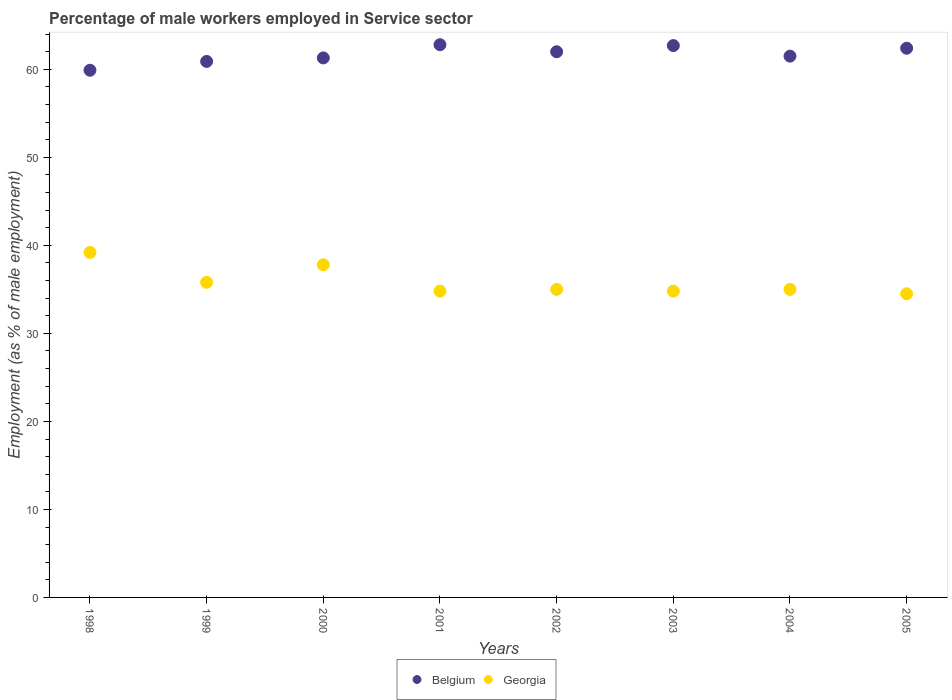What is the percentage of male workers employed in Service sector in Georgia in 2003?
Your response must be concise. 34.8. Across all years, what is the maximum percentage of male workers employed in Service sector in Belgium?
Your answer should be very brief. 62.8. Across all years, what is the minimum percentage of male workers employed in Service sector in Georgia?
Keep it short and to the point. 34.5. What is the total percentage of male workers employed in Service sector in Belgium in the graph?
Give a very brief answer. 493.5. What is the difference between the percentage of male workers employed in Service sector in Belgium in 2001 and that in 2004?
Offer a terse response. 1.3. What is the difference between the percentage of male workers employed in Service sector in Belgium in 2003 and the percentage of male workers employed in Service sector in Georgia in 1999?
Your answer should be compact. 26.9. What is the average percentage of male workers employed in Service sector in Georgia per year?
Keep it short and to the point. 35.86. In the year 1998, what is the difference between the percentage of male workers employed in Service sector in Belgium and percentage of male workers employed in Service sector in Georgia?
Offer a very short reply. 20.7. What is the ratio of the percentage of male workers employed in Service sector in Belgium in 2000 to that in 2004?
Keep it short and to the point. 1. Is the difference between the percentage of male workers employed in Service sector in Belgium in 2000 and 2001 greater than the difference between the percentage of male workers employed in Service sector in Georgia in 2000 and 2001?
Provide a succinct answer. No. What is the difference between the highest and the second highest percentage of male workers employed in Service sector in Belgium?
Offer a very short reply. 0.1. What is the difference between the highest and the lowest percentage of male workers employed in Service sector in Georgia?
Make the answer very short. 4.7. Is the sum of the percentage of male workers employed in Service sector in Georgia in 1998 and 2003 greater than the maximum percentage of male workers employed in Service sector in Belgium across all years?
Offer a terse response. Yes. Does the percentage of male workers employed in Service sector in Belgium monotonically increase over the years?
Provide a succinct answer. No. How many years are there in the graph?
Make the answer very short. 8. Are the values on the major ticks of Y-axis written in scientific E-notation?
Make the answer very short. No. Does the graph contain any zero values?
Your answer should be compact. No. How are the legend labels stacked?
Your answer should be compact. Horizontal. What is the title of the graph?
Give a very brief answer. Percentage of male workers employed in Service sector. What is the label or title of the X-axis?
Give a very brief answer. Years. What is the label or title of the Y-axis?
Make the answer very short. Employment (as % of male employment). What is the Employment (as % of male employment) of Belgium in 1998?
Give a very brief answer. 59.9. What is the Employment (as % of male employment) in Georgia in 1998?
Your answer should be very brief. 39.2. What is the Employment (as % of male employment) of Belgium in 1999?
Your answer should be very brief. 60.9. What is the Employment (as % of male employment) of Georgia in 1999?
Offer a very short reply. 35.8. What is the Employment (as % of male employment) of Belgium in 2000?
Make the answer very short. 61.3. What is the Employment (as % of male employment) in Georgia in 2000?
Provide a succinct answer. 37.8. What is the Employment (as % of male employment) in Belgium in 2001?
Keep it short and to the point. 62.8. What is the Employment (as % of male employment) of Georgia in 2001?
Keep it short and to the point. 34.8. What is the Employment (as % of male employment) of Georgia in 2002?
Provide a succinct answer. 35. What is the Employment (as % of male employment) in Belgium in 2003?
Ensure brevity in your answer.  62.7. What is the Employment (as % of male employment) in Georgia in 2003?
Ensure brevity in your answer.  34.8. What is the Employment (as % of male employment) of Belgium in 2004?
Make the answer very short. 61.5. What is the Employment (as % of male employment) of Georgia in 2004?
Your response must be concise. 35. What is the Employment (as % of male employment) in Belgium in 2005?
Offer a terse response. 62.4. What is the Employment (as % of male employment) of Georgia in 2005?
Ensure brevity in your answer.  34.5. Across all years, what is the maximum Employment (as % of male employment) in Belgium?
Your response must be concise. 62.8. Across all years, what is the maximum Employment (as % of male employment) of Georgia?
Keep it short and to the point. 39.2. Across all years, what is the minimum Employment (as % of male employment) in Belgium?
Keep it short and to the point. 59.9. Across all years, what is the minimum Employment (as % of male employment) in Georgia?
Keep it short and to the point. 34.5. What is the total Employment (as % of male employment) of Belgium in the graph?
Your answer should be compact. 493.5. What is the total Employment (as % of male employment) of Georgia in the graph?
Provide a short and direct response. 286.9. What is the difference between the Employment (as % of male employment) of Belgium in 1998 and that in 2001?
Your response must be concise. -2.9. What is the difference between the Employment (as % of male employment) of Belgium in 1998 and that in 2002?
Your answer should be very brief. -2.1. What is the difference between the Employment (as % of male employment) in Belgium in 1998 and that in 2004?
Give a very brief answer. -1.6. What is the difference between the Employment (as % of male employment) of Georgia in 1998 and that in 2004?
Offer a terse response. 4.2. What is the difference between the Employment (as % of male employment) of Georgia in 1998 and that in 2005?
Ensure brevity in your answer.  4.7. What is the difference between the Employment (as % of male employment) of Belgium in 1999 and that in 2000?
Your response must be concise. -0.4. What is the difference between the Employment (as % of male employment) in Georgia in 1999 and that in 2000?
Make the answer very short. -2. What is the difference between the Employment (as % of male employment) in Georgia in 1999 and that in 2001?
Your answer should be very brief. 1. What is the difference between the Employment (as % of male employment) of Georgia in 1999 and that in 2002?
Ensure brevity in your answer.  0.8. What is the difference between the Employment (as % of male employment) in Belgium in 1999 and that in 2003?
Provide a short and direct response. -1.8. What is the difference between the Employment (as % of male employment) in Georgia in 1999 and that in 2003?
Offer a terse response. 1. What is the difference between the Employment (as % of male employment) of Georgia in 1999 and that in 2004?
Offer a terse response. 0.8. What is the difference between the Employment (as % of male employment) of Belgium in 1999 and that in 2005?
Provide a short and direct response. -1.5. What is the difference between the Employment (as % of male employment) of Georgia in 1999 and that in 2005?
Provide a succinct answer. 1.3. What is the difference between the Employment (as % of male employment) of Belgium in 2000 and that in 2002?
Make the answer very short. -0.7. What is the difference between the Employment (as % of male employment) in Georgia in 2000 and that in 2003?
Your answer should be very brief. 3. What is the difference between the Employment (as % of male employment) of Georgia in 2000 and that in 2004?
Offer a terse response. 2.8. What is the difference between the Employment (as % of male employment) in Belgium in 2000 and that in 2005?
Provide a succinct answer. -1.1. What is the difference between the Employment (as % of male employment) in Belgium in 2001 and that in 2003?
Offer a terse response. 0.1. What is the difference between the Employment (as % of male employment) of Georgia in 2001 and that in 2003?
Give a very brief answer. 0. What is the difference between the Employment (as % of male employment) in Georgia in 2001 and that in 2004?
Your response must be concise. -0.2. What is the difference between the Employment (as % of male employment) of Georgia in 2001 and that in 2005?
Make the answer very short. 0.3. What is the difference between the Employment (as % of male employment) in Belgium in 2002 and that in 2004?
Make the answer very short. 0.5. What is the difference between the Employment (as % of male employment) in Georgia in 2002 and that in 2005?
Your answer should be very brief. 0.5. What is the difference between the Employment (as % of male employment) in Belgium in 2003 and that in 2004?
Provide a succinct answer. 1.2. What is the difference between the Employment (as % of male employment) of Georgia in 2003 and that in 2004?
Your answer should be very brief. -0.2. What is the difference between the Employment (as % of male employment) of Georgia in 2004 and that in 2005?
Ensure brevity in your answer.  0.5. What is the difference between the Employment (as % of male employment) of Belgium in 1998 and the Employment (as % of male employment) of Georgia in 1999?
Provide a short and direct response. 24.1. What is the difference between the Employment (as % of male employment) in Belgium in 1998 and the Employment (as % of male employment) in Georgia in 2000?
Your answer should be compact. 22.1. What is the difference between the Employment (as % of male employment) of Belgium in 1998 and the Employment (as % of male employment) of Georgia in 2001?
Make the answer very short. 25.1. What is the difference between the Employment (as % of male employment) of Belgium in 1998 and the Employment (as % of male employment) of Georgia in 2002?
Keep it short and to the point. 24.9. What is the difference between the Employment (as % of male employment) of Belgium in 1998 and the Employment (as % of male employment) of Georgia in 2003?
Your answer should be compact. 25.1. What is the difference between the Employment (as % of male employment) of Belgium in 1998 and the Employment (as % of male employment) of Georgia in 2004?
Make the answer very short. 24.9. What is the difference between the Employment (as % of male employment) in Belgium in 1998 and the Employment (as % of male employment) in Georgia in 2005?
Make the answer very short. 25.4. What is the difference between the Employment (as % of male employment) of Belgium in 1999 and the Employment (as % of male employment) of Georgia in 2000?
Provide a short and direct response. 23.1. What is the difference between the Employment (as % of male employment) of Belgium in 1999 and the Employment (as % of male employment) of Georgia in 2001?
Ensure brevity in your answer.  26.1. What is the difference between the Employment (as % of male employment) of Belgium in 1999 and the Employment (as % of male employment) of Georgia in 2002?
Your response must be concise. 25.9. What is the difference between the Employment (as % of male employment) of Belgium in 1999 and the Employment (as % of male employment) of Georgia in 2003?
Provide a succinct answer. 26.1. What is the difference between the Employment (as % of male employment) of Belgium in 1999 and the Employment (as % of male employment) of Georgia in 2004?
Keep it short and to the point. 25.9. What is the difference between the Employment (as % of male employment) in Belgium in 1999 and the Employment (as % of male employment) in Georgia in 2005?
Keep it short and to the point. 26.4. What is the difference between the Employment (as % of male employment) in Belgium in 2000 and the Employment (as % of male employment) in Georgia in 2001?
Your answer should be very brief. 26.5. What is the difference between the Employment (as % of male employment) in Belgium in 2000 and the Employment (as % of male employment) in Georgia in 2002?
Offer a very short reply. 26.3. What is the difference between the Employment (as % of male employment) of Belgium in 2000 and the Employment (as % of male employment) of Georgia in 2004?
Keep it short and to the point. 26.3. What is the difference between the Employment (as % of male employment) in Belgium in 2000 and the Employment (as % of male employment) in Georgia in 2005?
Your answer should be compact. 26.8. What is the difference between the Employment (as % of male employment) in Belgium in 2001 and the Employment (as % of male employment) in Georgia in 2002?
Make the answer very short. 27.8. What is the difference between the Employment (as % of male employment) in Belgium in 2001 and the Employment (as % of male employment) in Georgia in 2003?
Your response must be concise. 28. What is the difference between the Employment (as % of male employment) of Belgium in 2001 and the Employment (as % of male employment) of Georgia in 2004?
Your response must be concise. 27.8. What is the difference between the Employment (as % of male employment) of Belgium in 2001 and the Employment (as % of male employment) of Georgia in 2005?
Your answer should be compact. 28.3. What is the difference between the Employment (as % of male employment) in Belgium in 2002 and the Employment (as % of male employment) in Georgia in 2003?
Provide a short and direct response. 27.2. What is the difference between the Employment (as % of male employment) in Belgium in 2002 and the Employment (as % of male employment) in Georgia in 2004?
Your answer should be compact. 27. What is the difference between the Employment (as % of male employment) in Belgium in 2003 and the Employment (as % of male employment) in Georgia in 2004?
Make the answer very short. 27.7. What is the difference between the Employment (as % of male employment) in Belgium in 2003 and the Employment (as % of male employment) in Georgia in 2005?
Make the answer very short. 28.2. What is the difference between the Employment (as % of male employment) of Belgium in 2004 and the Employment (as % of male employment) of Georgia in 2005?
Offer a very short reply. 27. What is the average Employment (as % of male employment) in Belgium per year?
Offer a very short reply. 61.69. What is the average Employment (as % of male employment) in Georgia per year?
Keep it short and to the point. 35.86. In the year 1998, what is the difference between the Employment (as % of male employment) in Belgium and Employment (as % of male employment) in Georgia?
Make the answer very short. 20.7. In the year 1999, what is the difference between the Employment (as % of male employment) in Belgium and Employment (as % of male employment) in Georgia?
Keep it short and to the point. 25.1. In the year 2000, what is the difference between the Employment (as % of male employment) of Belgium and Employment (as % of male employment) of Georgia?
Provide a succinct answer. 23.5. In the year 2001, what is the difference between the Employment (as % of male employment) in Belgium and Employment (as % of male employment) in Georgia?
Ensure brevity in your answer.  28. In the year 2003, what is the difference between the Employment (as % of male employment) of Belgium and Employment (as % of male employment) of Georgia?
Provide a succinct answer. 27.9. In the year 2005, what is the difference between the Employment (as % of male employment) of Belgium and Employment (as % of male employment) of Georgia?
Provide a short and direct response. 27.9. What is the ratio of the Employment (as % of male employment) of Belgium in 1998 to that in 1999?
Provide a short and direct response. 0.98. What is the ratio of the Employment (as % of male employment) of Georgia in 1998 to that in 1999?
Provide a succinct answer. 1.09. What is the ratio of the Employment (as % of male employment) of Belgium in 1998 to that in 2000?
Ensure brevity in your answer.  0.98. What is the ratio of the Employment (as % of male employment) of Georgia in 1998 to that in 2000?
Make the answer very short. 1.04. What is the ratio of the Employment (as % of male employment) in Belgium in 1998 to that in 2001?
Your response must be concise. 0.95. What is the ratio of the Employment (as % of male employment) in Georgia in 1998 to that in 2001?
Ensure brevity in your answer.  1.13. What is the ratio of the Employment (as % of male employment) in Belgium in 1998 to that in 2002?
Give a very brief answer. 0.97. What is the ratio of the Employment (as % of male employment) in Georgia in 1998 to that in 2002?
Provide a succinct answer. 1.12. What is the ratio of the Employment (as % of male employment) in Belgium in 1998 to that in 2003?
Offer a very short reply. 0.96. What is the ratio of the Employment (as % of male employment) of Georgia in 1998 to that in 2003?
Provide a succinct answer. 1.13. What is the ratio of the Employment (as % of male employment) in Georgia in 1998 to that in 2004?
Make the answer very short. 1.12. What is the ratio of the Employment (as % of male employment) of Belgium in 1998 to that in 2005?
Your answer should be compact. 0.96. What is the ratio of the Employment (as % of male employment) of Georgia in 1998 to that in 2005?
Keep it short and to the point. 1.14. What is the ratio of the Employment (as % of male employment) in Belgium in 1999 to that in 2000?
Ensure brevity in your answer.  0.99. What is the ratio of the Employment (as % of male employment) of Georgia in 1999 to that in 2000?
Your answer should be compact. 0.95. What is the ratio of the Employment (as % of male employment) of Belgium in 1999 to that in 2001?
Ensure brevity in your answer.  0.97. What is the ratio of the Employment (as % of male employment) of Georgia in 1999 to that in 2001?
Make the answer very short. 1.03. What is the ratio of the Employment (as % of male employment) in Belgium in 1999 to that in 2002?
Your response must be concise. 0.98. What is the ratio of the Employment (as % of male employment) of Georgia in 1999 to that in 2002?
Make the answer very short. 1.02. What is the ratio of the Employment (as % of male employment) in Belgium in 1999 to that in 2003?
Provide a succinct answer. 0.97. What is the ratio of the Employment (as % of male employment) of Georgia in 1999 to that in 2003?
Give a very brief answer. 1.03. What is the ratio of the Employment (as % of male employment) of Belgium in 1999 to that in 2004?
Offer a terse response. 0.99. What is the ratio of the Employment (as % of male employment) in Georgia in 1999 to that in 2004?
Offer a very short reply. 1.02. What is the ratio of the Employment (as % of male employment) in Georgia in 1999 to that in 2005?
Give a very brief answer. 1.04. What is the ratio of the Employment (as % of male employment) of Belgium in 2000 to that in 2001?
Your answer should be very brief. 0.98. What is the ratio of the Employment (as % of male employment) of Georgia in 2000 to that in 2001?
Make the answer very short. 1.09. What is the ratio of the Employment (as % of male employment) of Belgium in 2000 to that in 2002?
Your answer should be very brief. 0.99. What is the ratio of the Employment (as % of male employment) of Georgia in 2000 to that in 2002?
Provide a short and direct response. 1.08. What is the ratio of the Employment (as % of male employment) of Belgium in 2000 to that in 2003?
Make the answer very short. 0.98. What is the ratio of the Employment (as % of male employment) of Georgia in 2000 to that in 2003?
Give a very brief answer. 1.09. What is the ratio of the Employment (as % of male employment) in Belgium in 2000 to that in 2004?
Your answer should be compact. 1. What is the ratio of the Employment (as % of male employment) in Georgia in 2000 to that in 2004?
Offer a very short reply. 1.08. What is the ratio of the Employment (as % of male employment) of Belgium in 2000 to that in 2005?
Your answer should be very brief. 0.98. What is the ratio of the Employment (as % of male employment) in Georgia in 2000 to that in 2005?
Your answer should be compact. 1.1. What is the ratio of the Employment (as % of male employment) in Belgium in 2001 to that in 2002?
Offer a terse response. 1.01. What is the ratio of the Employment (as % of male employment) of Georgia in 2001 to that in 2002?
Your answer should be compact. 0.99. What is the ratio of the Employment (as % of male employment) of Belgium in 2001 to that in 2003?
Offer a very short reply. 1. What is the ratio of the Employment (as % of male employment) of Belgium in 2001 to that in 2004?
Provide a succinct answer. 1.02. What is the ratio of the Employment (as % of male employment) of Belgium in 2001 to that in 2005?
Give a very brief answer. 1.01. What is the ratio of the Employment (as % of male employment) in Georgia in 2001 to that in 2005?
Ensure brevity in your answer.  1.01. What is the ratio of the Employment (as % of male employment) of Georgia in 2002 to that in 2004?
Make the answer very short. 1. What is the ratio of the Employment (as % of male employment) of Georgia in 2002 to that in 2005?
Your answer should be very brief. 1.01. What is the ratio of the Employment (as % of male employment) in Belgium in 2003 to that in 2004?
Provide a short and direct response. 1.02. What is the ratio of the Employment (as % of male employment) of Georgia in 2003 to that in 2005?
Offer a terse response. 1.01. What is the ratio of the Employment (as % of male employment) of Belgium in 2004 to that in 2005?
Your answer should be very brief. 0.99. What is the ratio of the Employment (as % of male employment) of Georgia in 2004 to that in 2005?
Offer a terse response. 1.01. What is the difference between the highest and the second highest Employment (as % of male employment) of Belgium?
Offer a very short reply. 0.1. What is the difference between the highest and the lowest Employment (as % of male employment) of Belgium?
Your response must be concise. 2.9. 